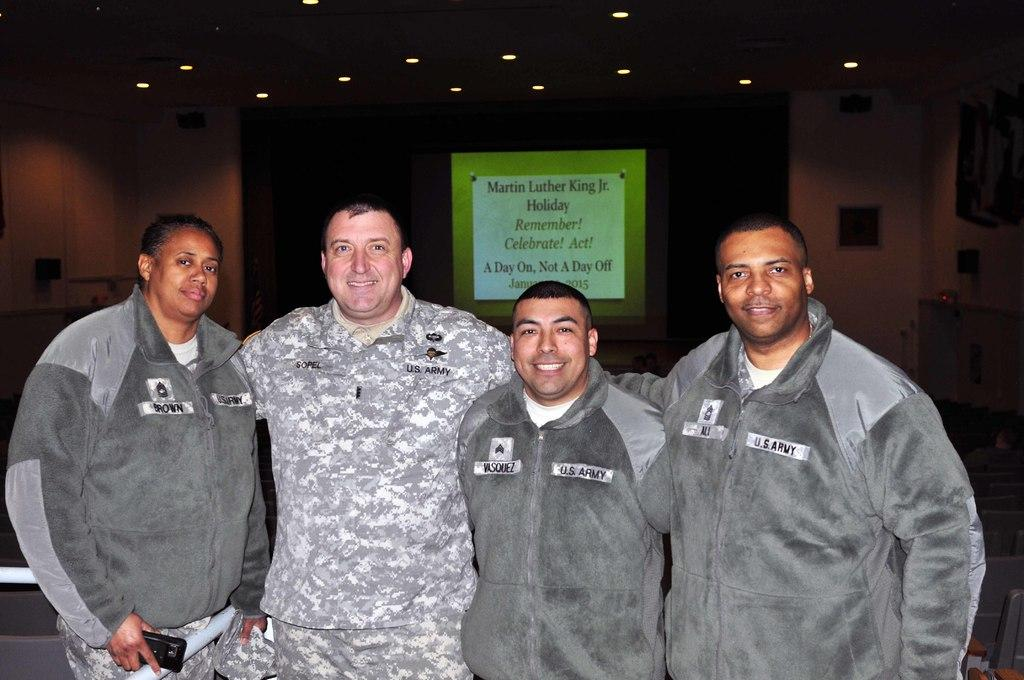How many people are present in the image? There are four people standing in the image. What is the person on the left holding? The person on the left is holding a mobile. What can be seen in the background of the image? There is a poster visible in the background of the image. What type of lighting is present in the image? There are lights on the ceiling in the image. What invention is being demonstrated by the person on the right in the image? There is no invention being demonstrated by the person on the right in the image. What type of sign is visible on the poster in the background? The poster in the background does not have a sign; it is a solid color with no text or images. 